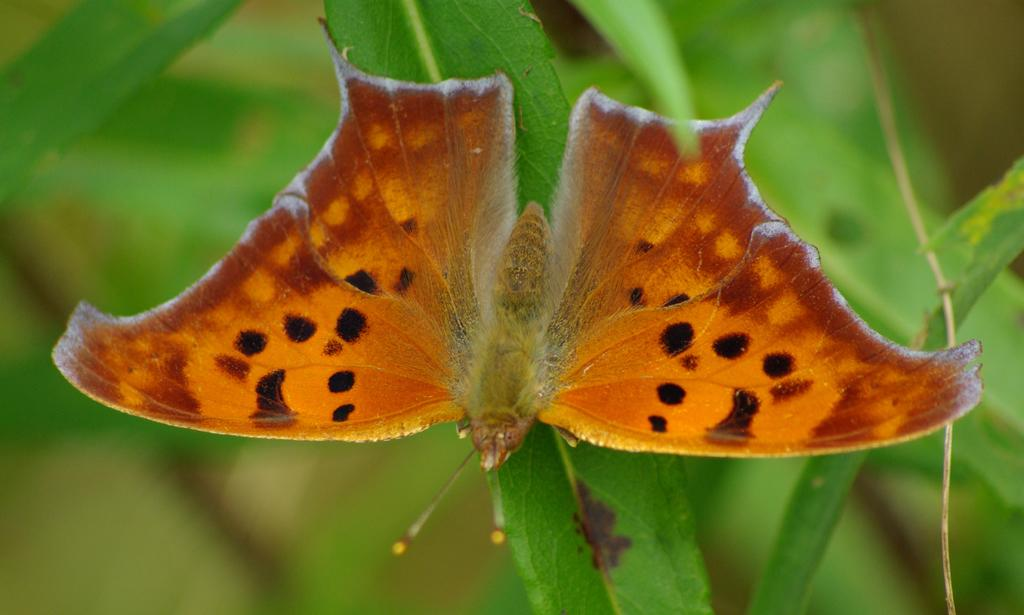What is the main subject of the image? There is a butterfly in the image. Can you describe the color of the butterfly? The butterfly is brown in color. Where is the butterfly located in the image? The butterfly is on the leaves of a plant. What type of chair can be seen in the image? There is no chair present in the image; it features a brown butterfly on the leaves of a plant. Is there any eggnog visible in the image? There is no eggnog present in the image. 